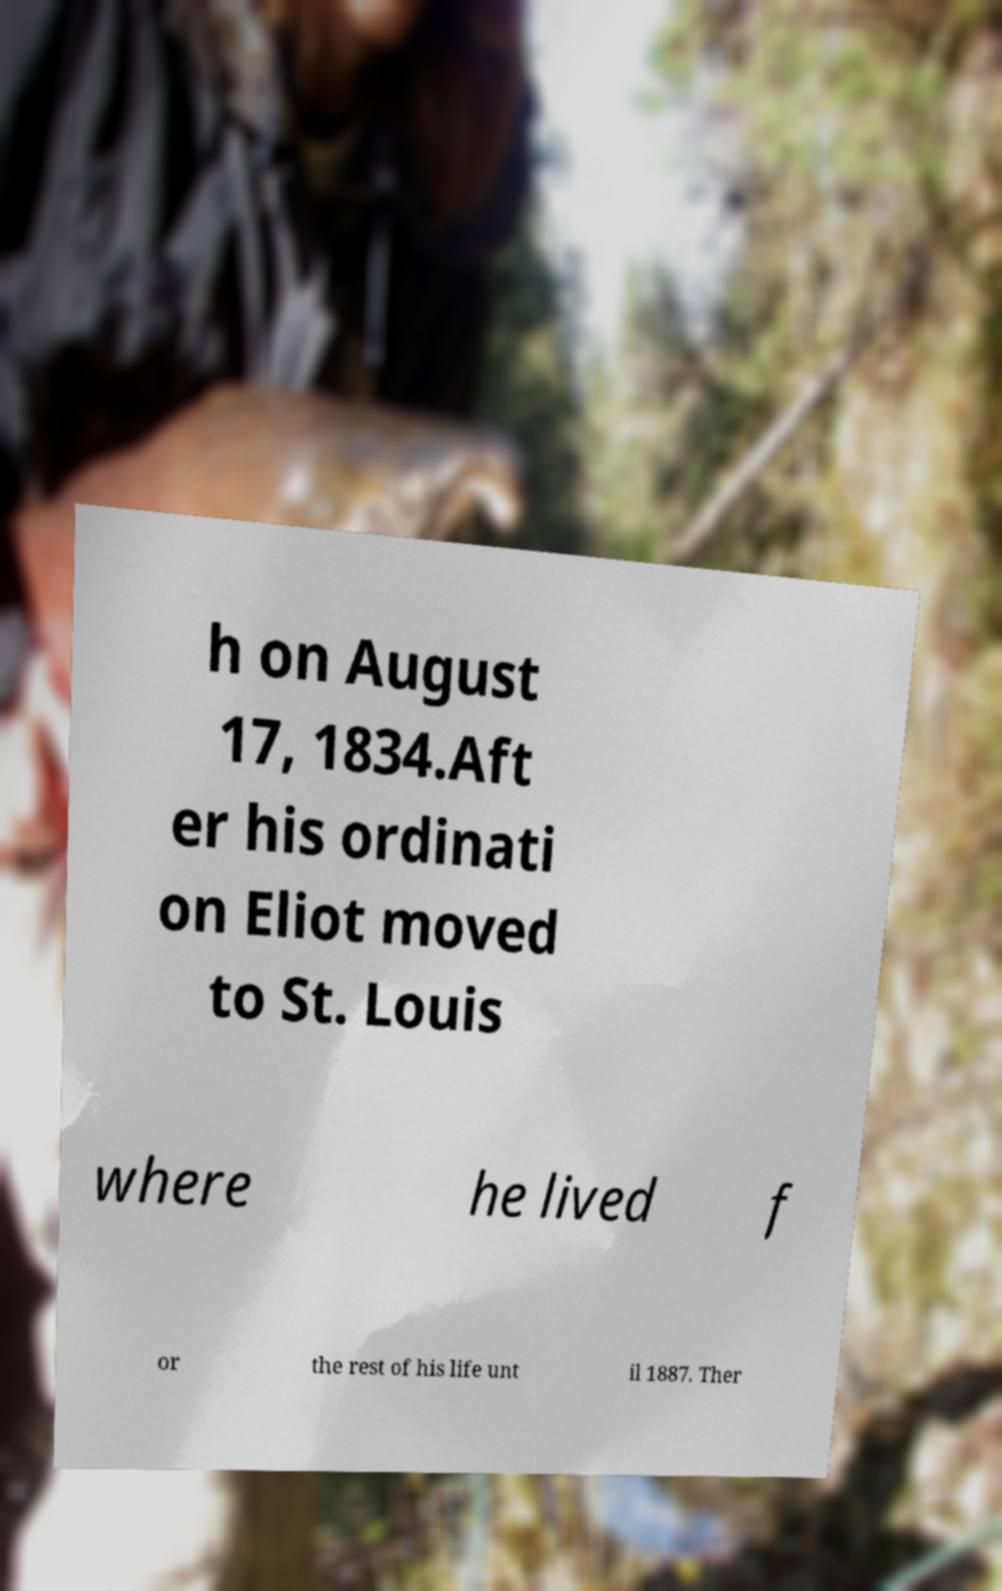Please identify and transcribe the text found in this image. h on August 17, 1834.Aft er his ordinati on Eliot moved to St. Louis where he lived f or the rest of his life unt il 1887. Ther 